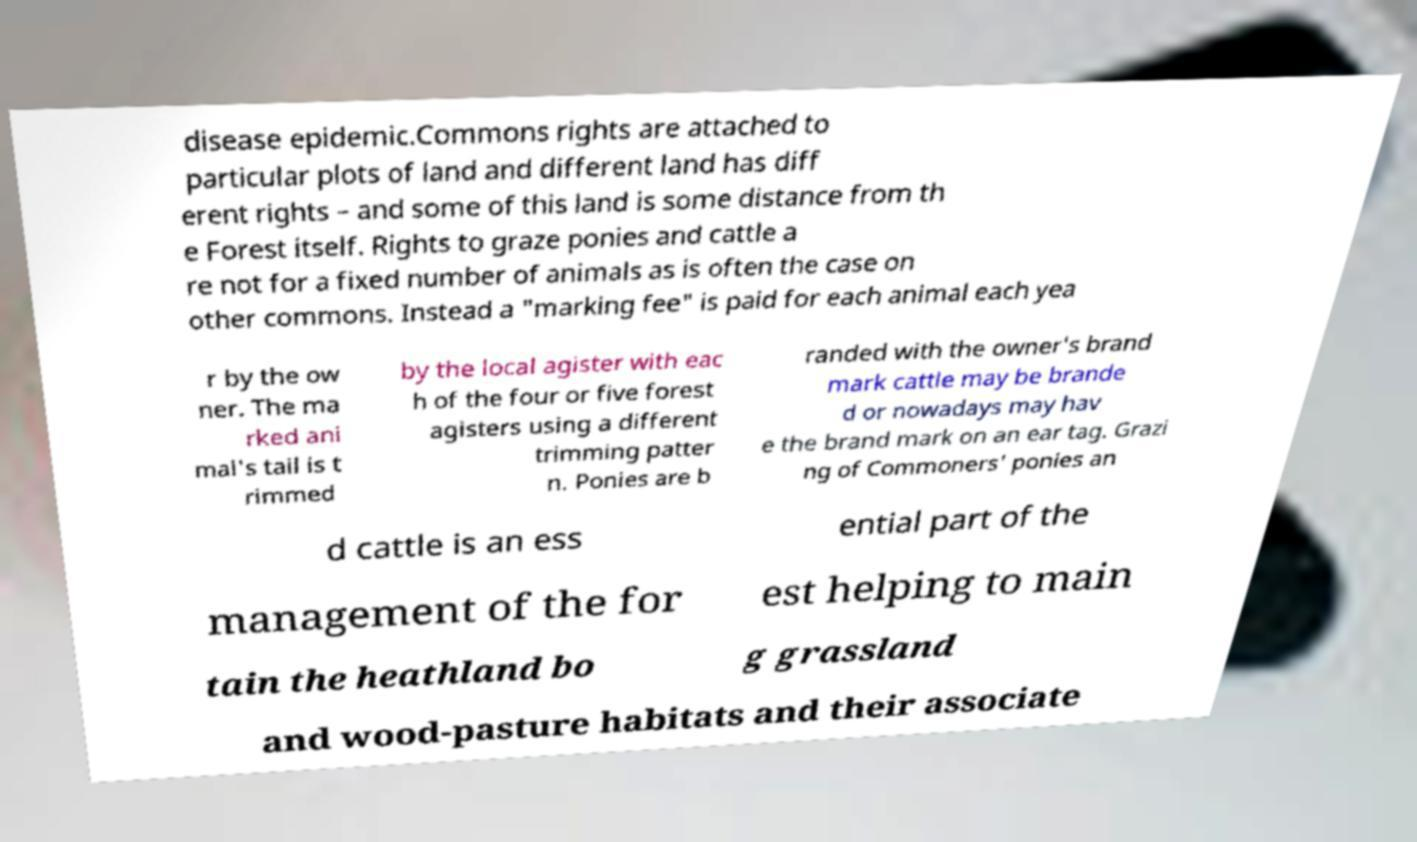I need the written content from this picture converted into text. Can you do that? disease epidemic.Commons rights are attached to particular plots of land and different land has diff erent rights – and some of this land is some distance from th e Forest itself. Rights to graze ponies and cattle a re not for a fixed number of animals as is often the case on other commons. Instead a "marking fee" is paid for each animal each yea r by the ow ner. The ma rked ani mal's tail is t rimmed by the local agister with eac h of the four or five forest agisters using a different trimming patter n. Ponies are b randed with the owner's brand mark cattle may be brande d or nowadays may hav e the brand mark on an ear tag. Grazi ng of Commoners' ponies an d cattle is an ess ential part of the management of the for est helping to main tain the heathland bo g grassland and wood-pasture habitats and their associate 